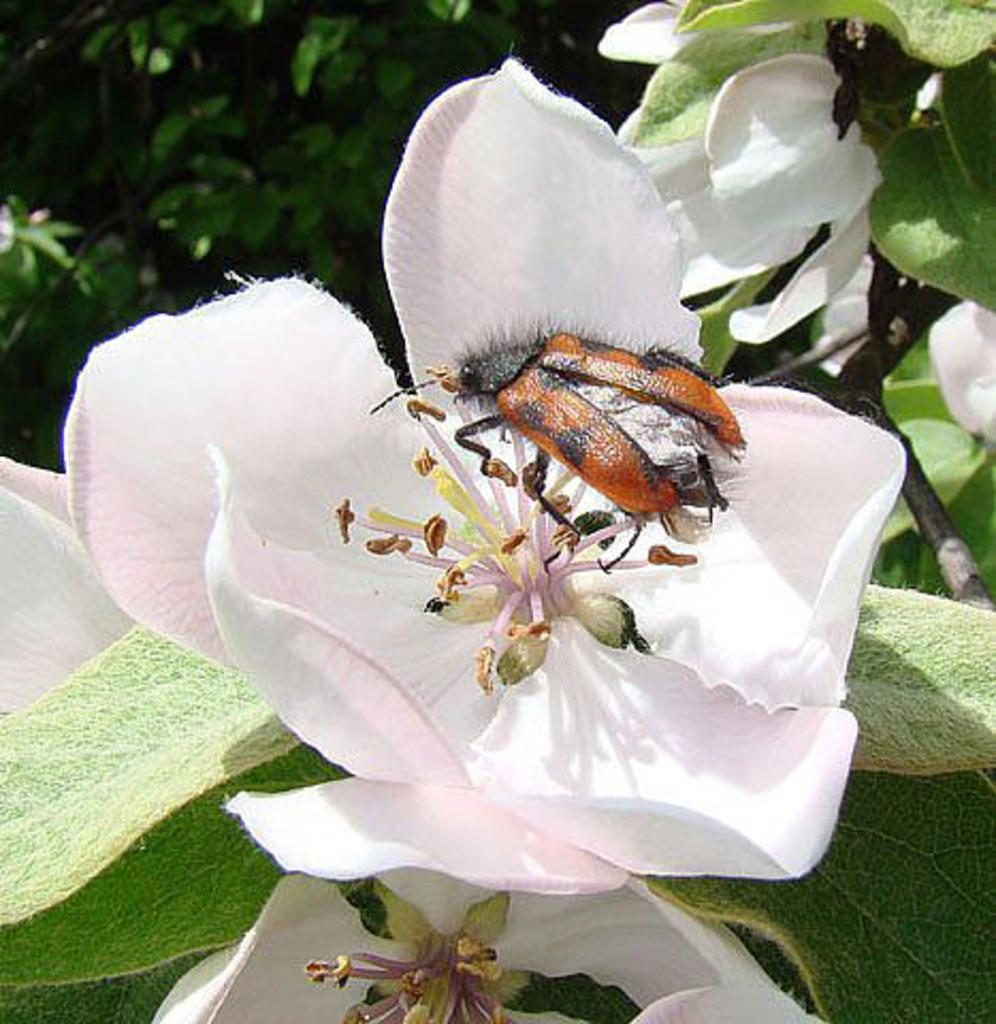What is the main subject in the center of the image? There is a flower in the center of the image. Are there any other creatures or objects on the flower? Yes, there is a bug on the flower. What else can be seen in the image besides the flower and bug? There are leaves in the image. What is the surrounding environment like in the image? There are other flowers around the area of the image. What is the name of the range of mountains visible in the image? There are no mountains visible in the image; it features a flower with a bug and leaves. 